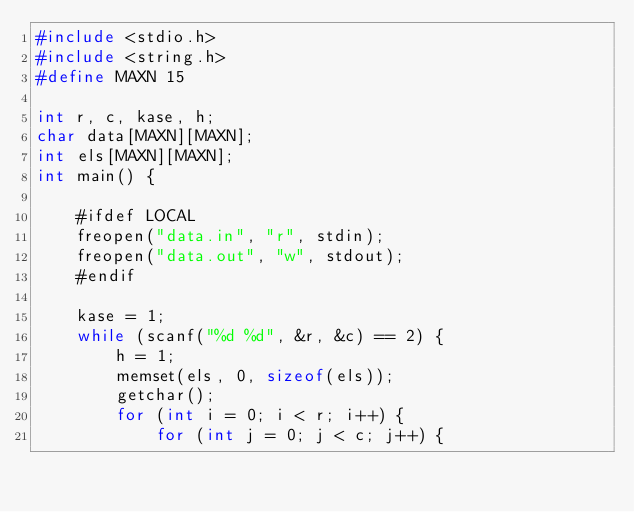Convert code to text. <code><loc_0><loc_0><loc_500><loc_500><_C++_>#include <stdio.h>
#include <string.h>
#define MAXN 15

int r, c, kase, h;
char data[MAXN][MAXN];
int els[MAXN][MAXN];
int main() {
    
    #ifdef LOCAL
    freopen("data.in", "r", stdin);
    freopen("data.out", "w", stdout);
    #endif
    
    kase = 1;
    while (scanf("%d %d", &r, &c) == 2) {
        h = 1;
        memset(els, 0, sizeof(els));
        getchar();
        for (int i = 0; i < r; i++) {
            for (int j = 0; j < c; j++) {</code> 